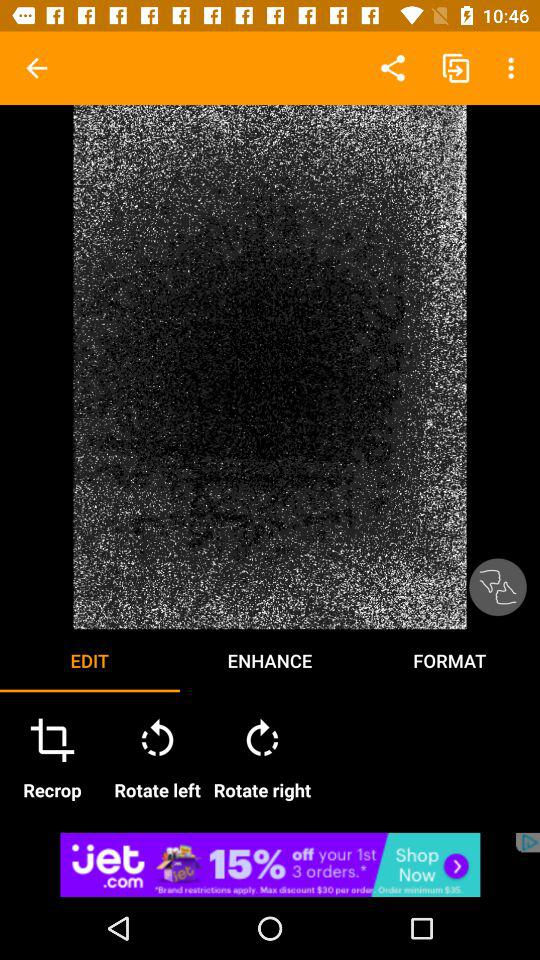Which tab is selected? The selected tab is "EDIT". 